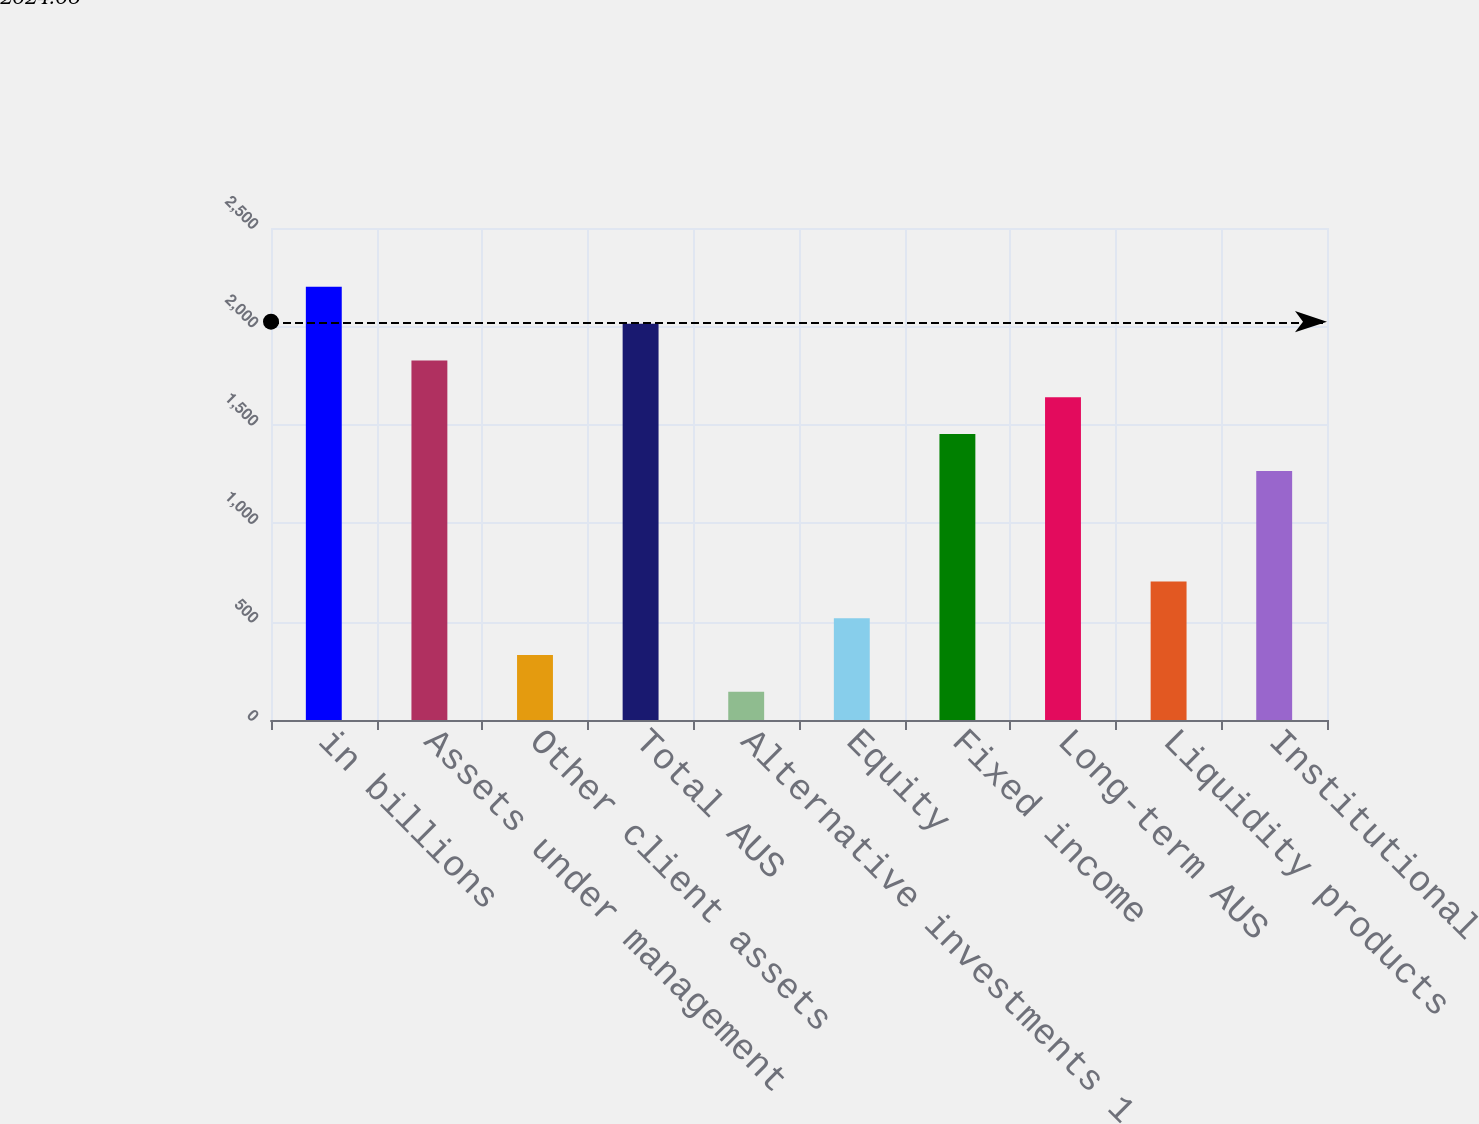Convert chart to OTSL. <chart><loc_0><loc_0><loc_500><loc_500><bar_chart><fcel>in billions<fcel>Assets under management<fcel>Other client assets<fcel>Total AUS<fcel>Alternative investments 1<fcel>Equity<fcel>Fixed income<fcel>Long-term AUS<fcel>Liquidity products<fcel>Institutional<nl><fcel>2201.1<fcel>1826.9<fcel>330.1<fcel>2014<fcel>143<fcel>517.2<fcel>1452.7<fcel>1639.8<fcel>704.3<fcel>1265.6<nl></chart> 